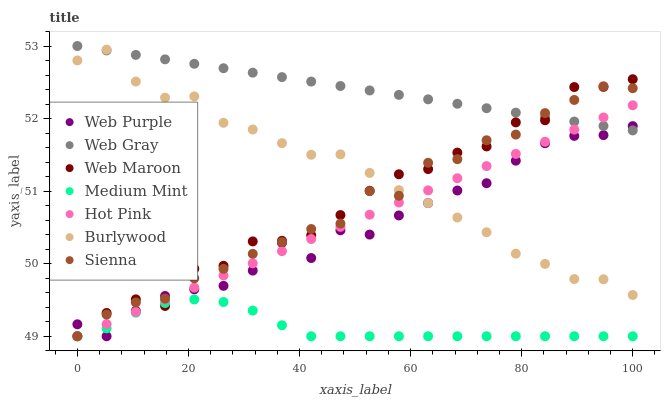Does Medium Mint have the minimum area under the curve?
Answer yes or no. Yes. Does Web Gray have the maximum area under the curve?
Answer yes or no. Yes. Does Burlywood have the minimum area under the curve?
Answer yes or no. No. Does Burlywood have the maximum area under the curve?
Answer yes or no. No. Is Hot Pink the smoothest?
Answer yes or no. Yes. Is Web Maroon the roughest?
Answer yes or no. Yes. Is Web Gray the smoothest?
Answer yes or no. No. Is Web Gray the roughest?
Answer yes or no. No. Does Medium Mint have the lowest value?
Answer yes or no. Yes. Does Burlywood have the lowest value?
Answer yes or no. No. Does Web Gray have the highest value?
Answer yes or no. Yes. Does Burlywood have the highest value?
Answer yes or no. No. Is Medium Mint less than Burlywood?
Answer yes or no. Yes. Is Web Gray greater than Medium Mint?
Answer yes or no. Yes. Does Burlywood intersect Hot Pink?
Answer yes or no. Yes. Is Burlywood less than Hot Pink?
Answer yes or no. No. Is Burlywood greater than Hot Pink?
Answer yes or no. No. Does Medium Mint intersect Burlywood?
Answer yes or no. No. 